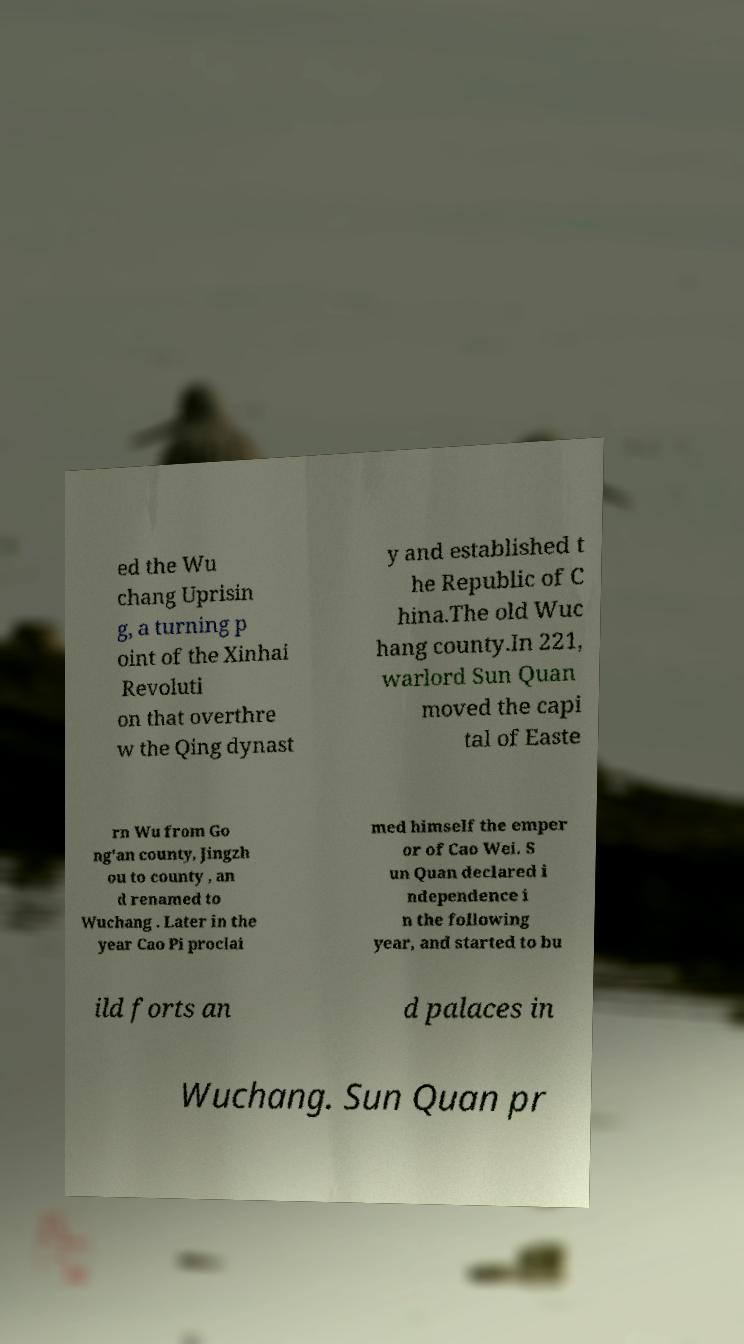Please identify and transcribe the text found in this image. ed the Wu chang Uprisin g, a turning p oint of the Xinhai Revoluti on that overthre w the Qing dynast y and established t he Republic of C hina.The old Wuc hang county.In 221, warlord Sun Quan moved the capi tal of Easte rn Wu from Go ng'an county, Jingzh ou to county , an d renamed to Wuchang . Later in the year Cao Pi proclai med himself the emper or of Cao Wei. S un Quan declared i ndependence i n the following year, and started to bu ild forts an d palaces in Wuchang. Sun Quan pr 